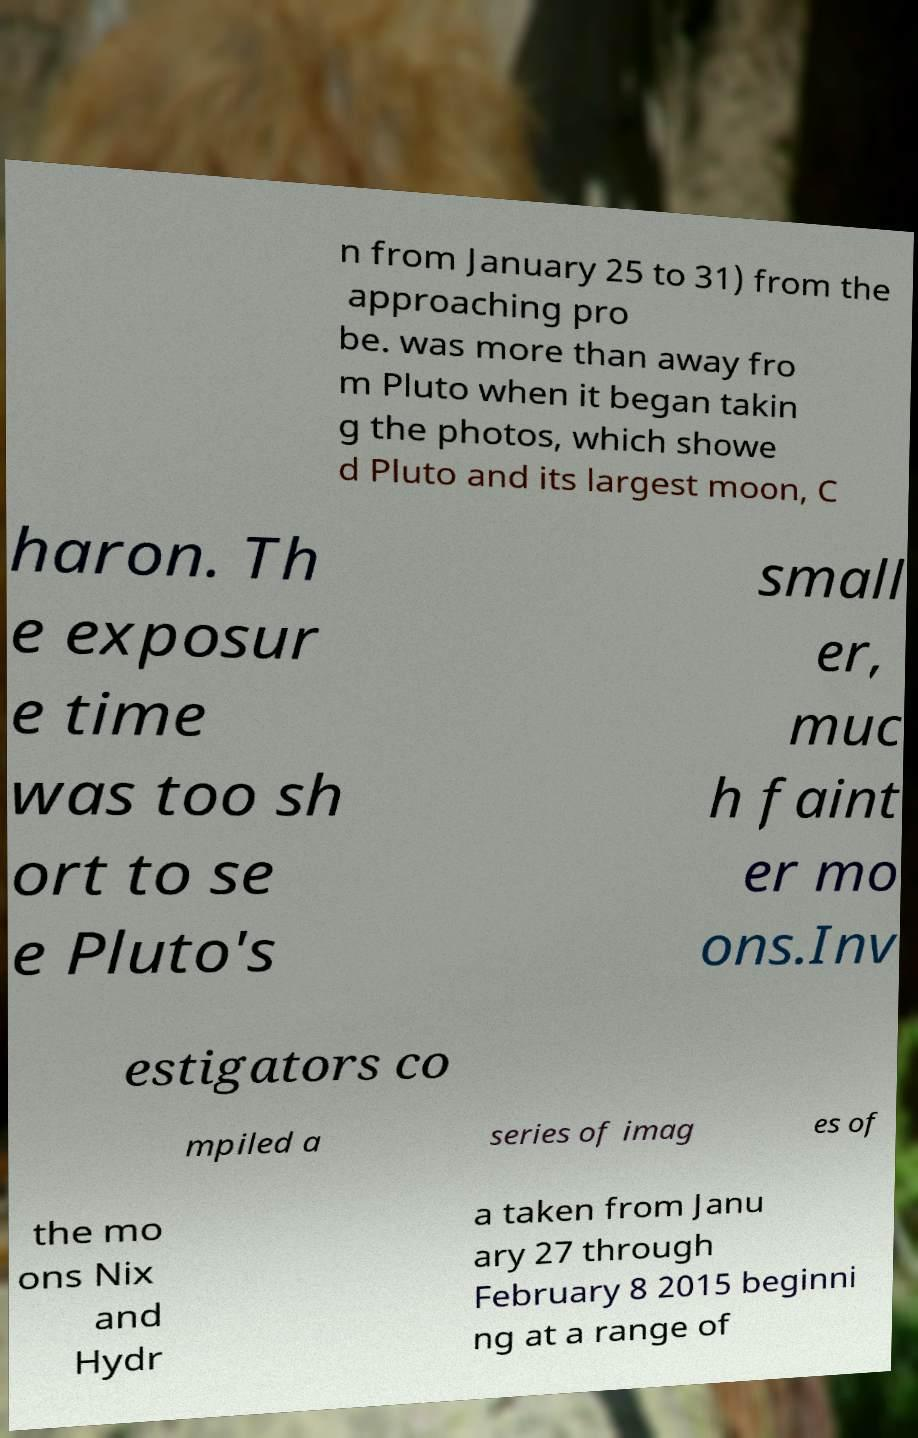I need the written content from this picture converted into text. Can you do that? n from January 25 to 31) from the approaching pro be. was more than away fro m Pluto when it began takin g the photos, which showe d Pluto and its largest moon, C haron. Th e exposur e time was too sh ort to se e Pluto's small er, muc h faint er mo ons.Inv estigators co mpiled a series of imag es of the mo ons Nix and Hydr a taken from Janu ary 27 through February 8 2015 beginni ng at a range of 